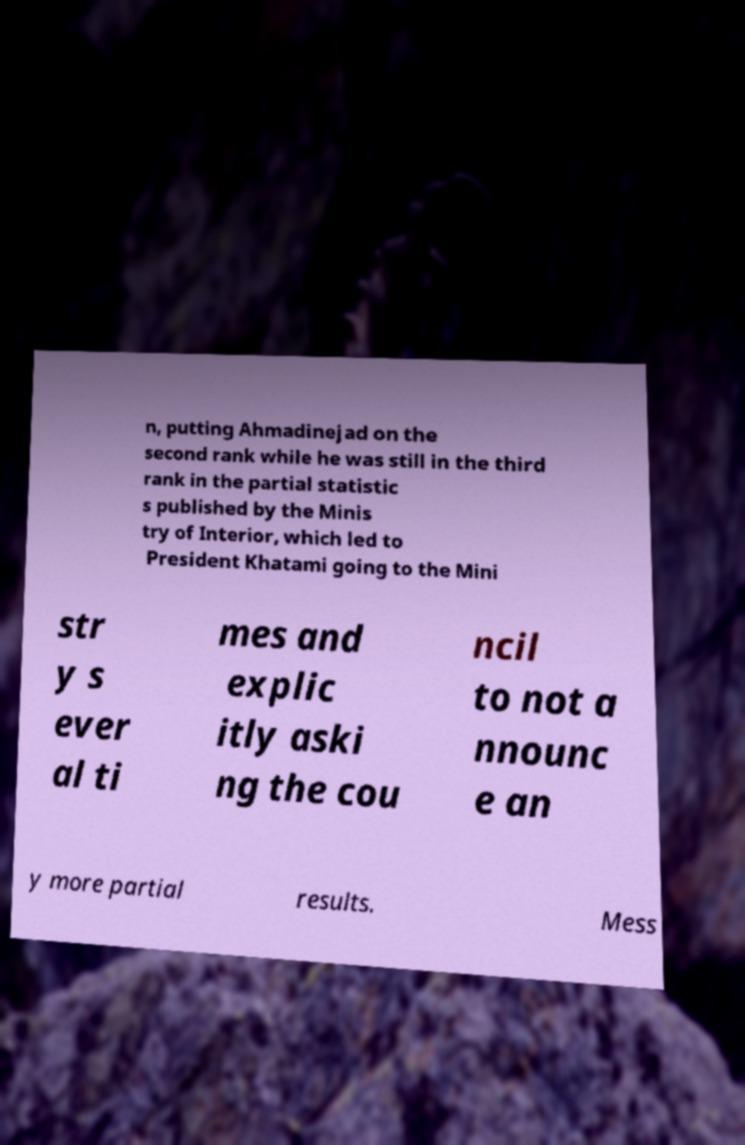I need the written content from this picture converted into text. Can you do that? n, putting Ahmadinejad on the second rank while he was still in the third rank in the partial statistic s published by the Minis try of Interior, which led to President Khatami going to the Mini str y s ever al ti mes and explic itly aski ng the cou ncil to not a nnounc e an y more partial results. Mess 